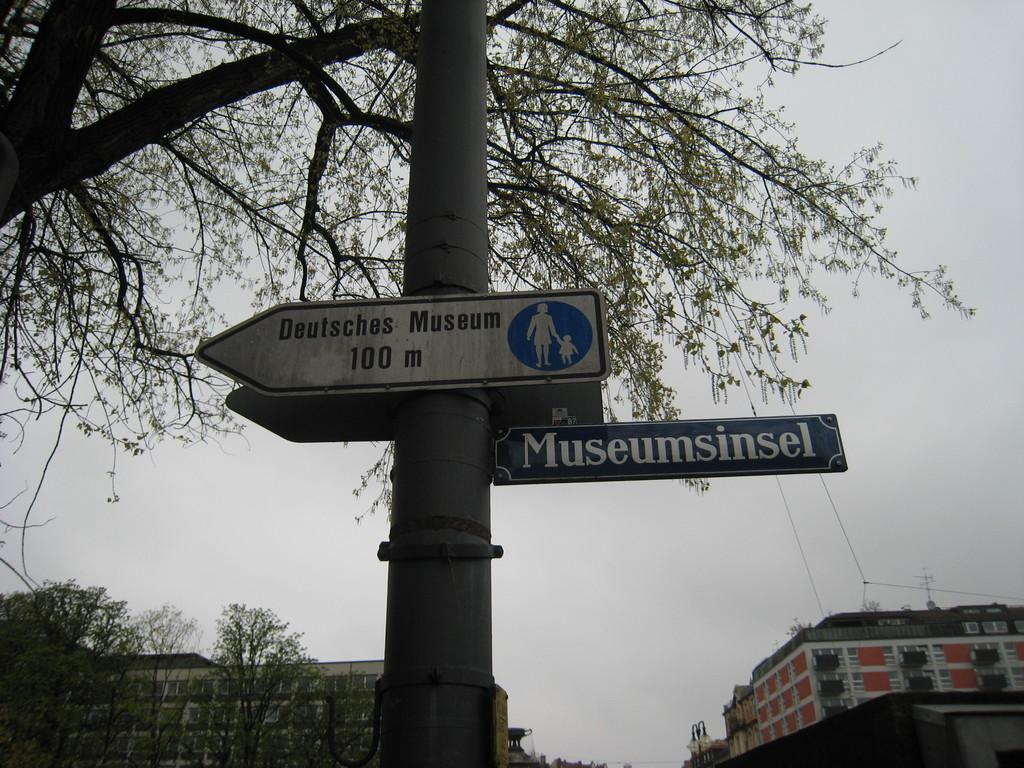What type of natural elements can be seen in the image? There are many trees in the image. What part of the natural environment is visible in the image? The sky is visible in the image. What structure is present in the image? There is a pole in the image. What is attached to the pole? Directional boards are attached to the pole. What else can be seen in the image? There are cables in the image. What is the size of the wall in the image? There is no wall present in the image. What type of birth can be seen in the image? There is no birth depicted in the image. 